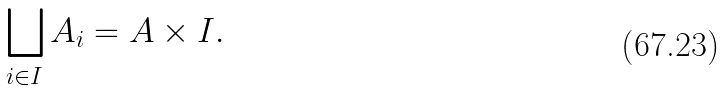Convert formula to latex. <formula><loc_0><loc_0><loc_500><loc_500>\bigsqcup _ { i \in I } A _ { i } = A \times I .</formula> 